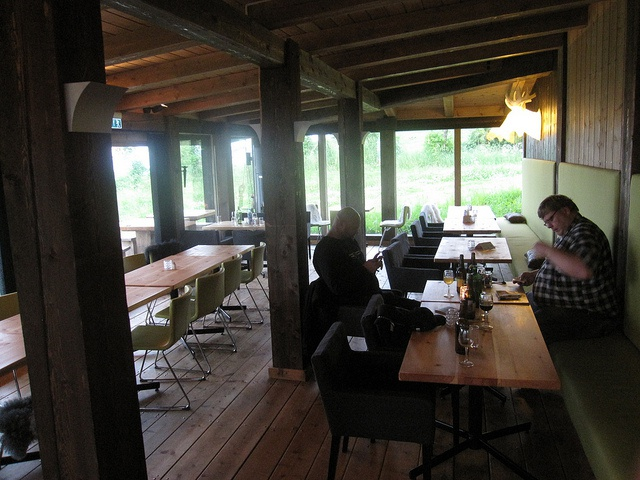Describe the objects in this image and their specific colors. I can see dining table in black, maroon, and gray tones, people in black, gray, and maroon tones, chair in black, gray, and maroon tones, people in black and gray tones, and dining table in black, gray, darkgray, and lavender tones in this image. 